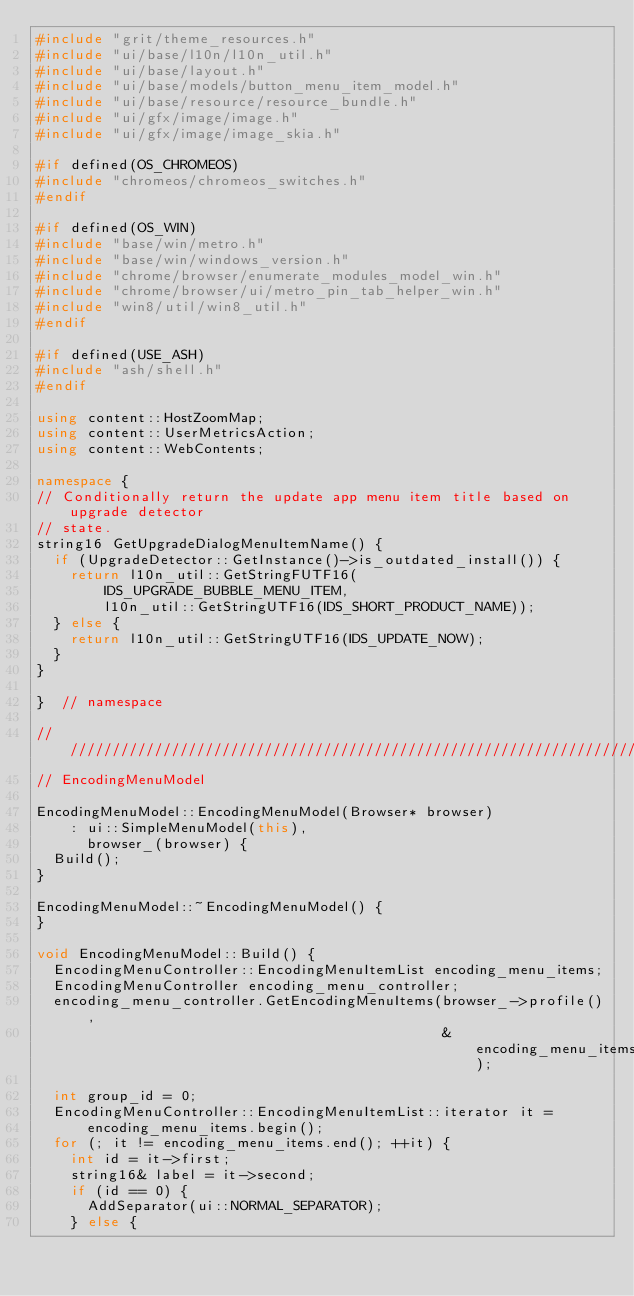Convert code to text. <code><loc_0><loc_0><loc_500><loc_500><_C++_>#include "grit/theme_resources.h"
#include "ui/base/l10n/l10n_util.h"
#include "ui/base/layout.h"
#include "ui/base/models/button_menu_item_model.h"
#include "ui/base/resource/resource_bundle.h"
#include "ui/gfx/image/image.h"
#include "ui/gfx/image/image_skia.h"

#if defined(OS_CHROMEOS)
#include "chromeos/chromeos_switches.h"
#endif

#if defined(OS_WIN)
#include "base/win/metro.h"
#include "base/win/windows_version.h"
#include "chrome/browser/enumerate_modules_model_win.h"
#include "chrome/browser/ui/metro_pin_tab_helper_win.h"
#include "win8/util/win8_util.h"
#endif

#if defined(USE_ASH)
#include "ash/shell.h"
#endif

using content::HostZoomMap;
using content::UserMetricsAction;
using content::WebContents;

namespace {
// Conditionally return the update app menu item title based on upgrade detector
// state.
string16 GetUpgradeDialogMenuItemName() {
  if (UpgradeDetector::GetInstance()->is_outdated_install()) {
    return l10n_util::GetStringFUTF16(
        IDS_UPGRADE_BUBBLE_MENU_ITEM,
        l10n_util::GetStringUTF16(IDS_SHORT_PRODUCT_NAME));
  } else {
    return l10n_util::GetStringUTF16(IDS_UPDATE_NOW);
  }
}

}  // namespace

////////////////////////////////////////////////////////////////////////////////
// EncodingMenuModel

EncodingMenuModel::EncodingMenuModel(Browser* browser)
    : ui::SimpleMenuModel(this),
      browser_(browser) {
  Build();
}

EncodingMenuModel::~EncodingMenuModel() {
}

void EncodingMenuModel::Build() {
  EncodingMenuController::EncodingMenuItemList encoding_menu_items;
  EncodingMenuController encoding_menu_controller;
  encoding_menu_controller.GetEncodingMenuItems(browser_->profile(),
                                                &encoding_menu_items);

  int group_id = 0;
  EncodingMenuController::EncodingMenuItemList::iterator it =
      encoding_menu_items.begin();
  for (; it != encoding_menu_items.end(); ++it) {
    int id = it->first;
    string16& label = it->second;
    if (id == 0) {
      AddSeparator(ui::NORMAL_SEPARATOR);
    } else {</code> 